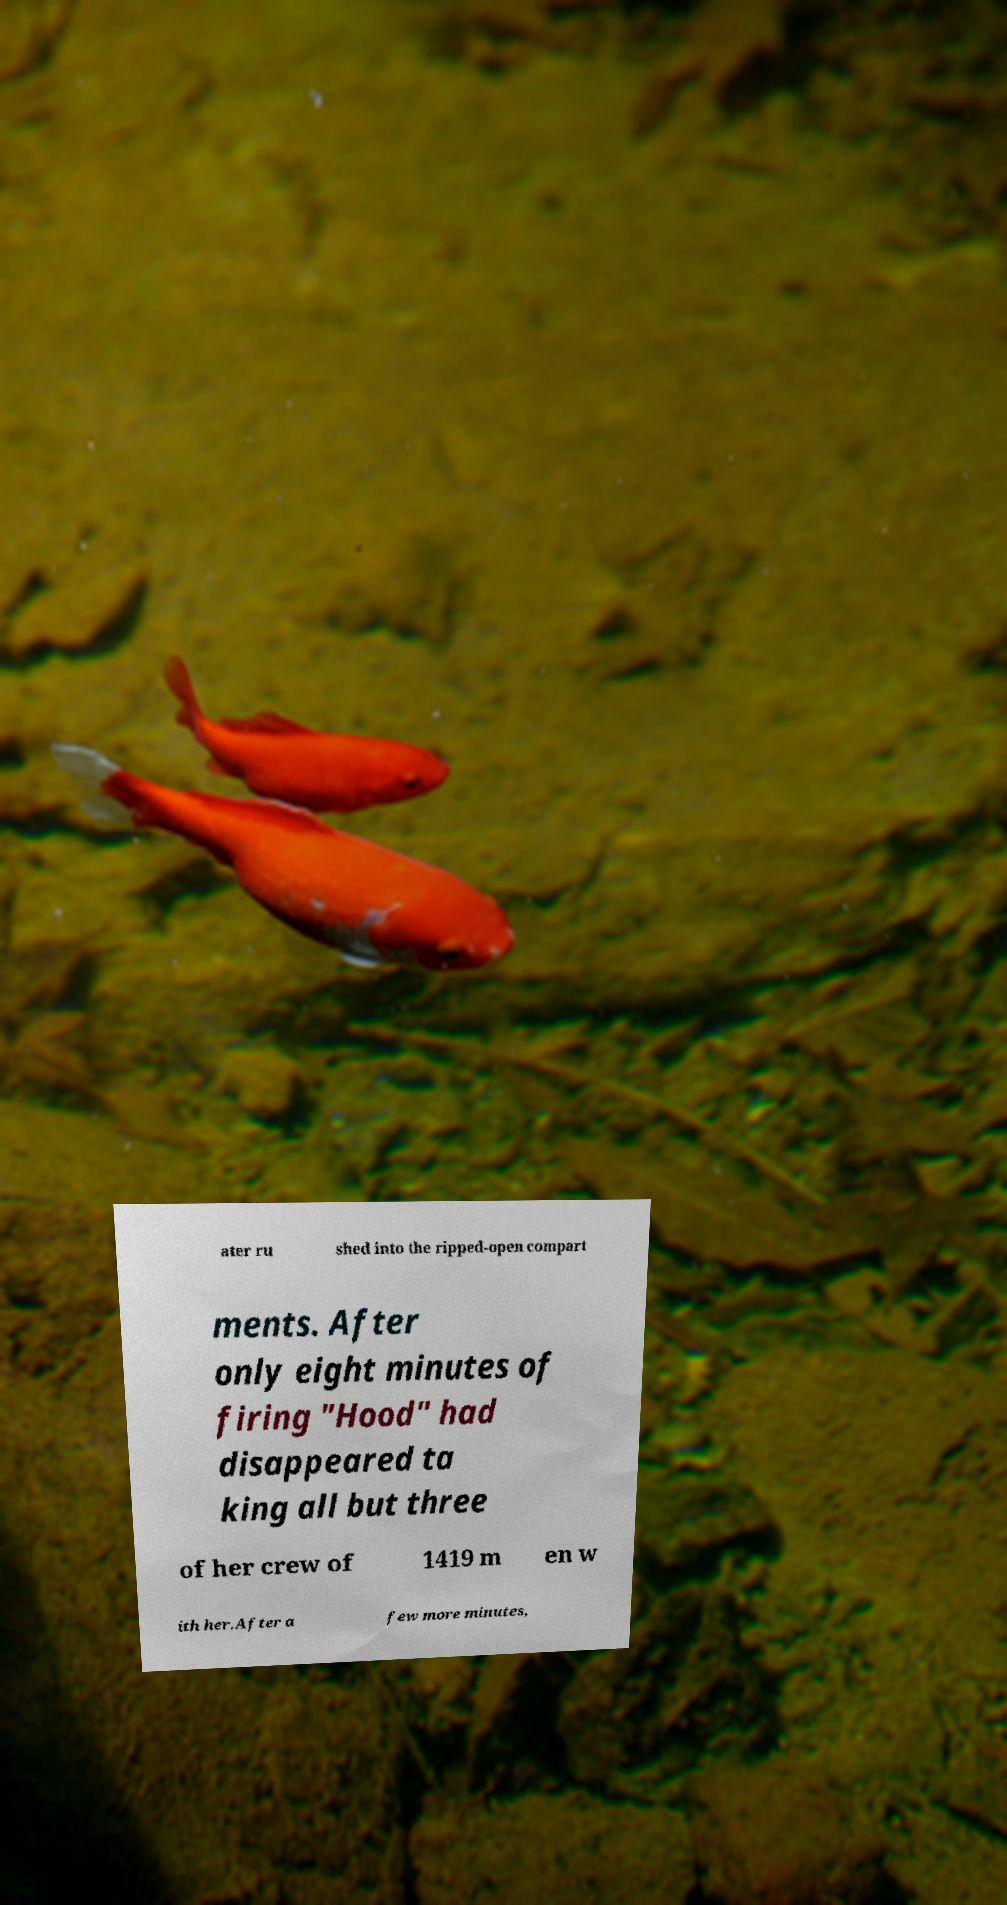Can you accurately transcribe the text from the provided image for me? ater ru shed into the ripped-open compart ments. After only eight minutes of firing "Hood" had disappeared ta king all but three of her crew of 1419 m en w ith her.After a few more minutes, 